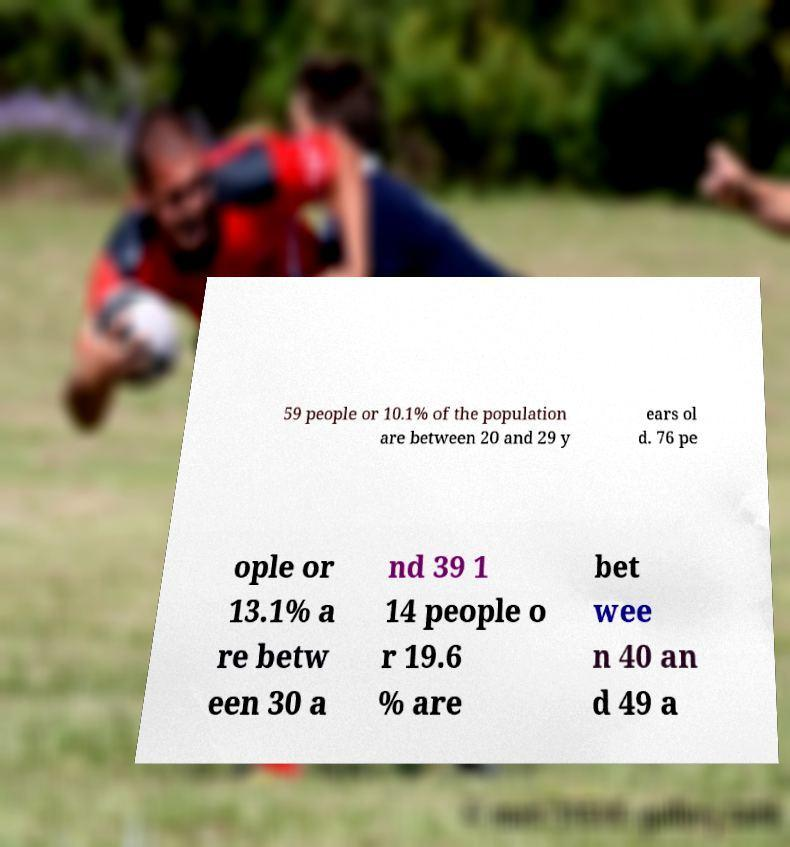Could you assist in decoding the text presented in this image and type it out clearly? 59 people or 10.1% of the population are between 20 and 29 y ears ol d. 76 pe ople or 13.1% a re betw een 30 a nd 39 1 14 people o r 19.6 % are bet wee n 40 an d 49 a 